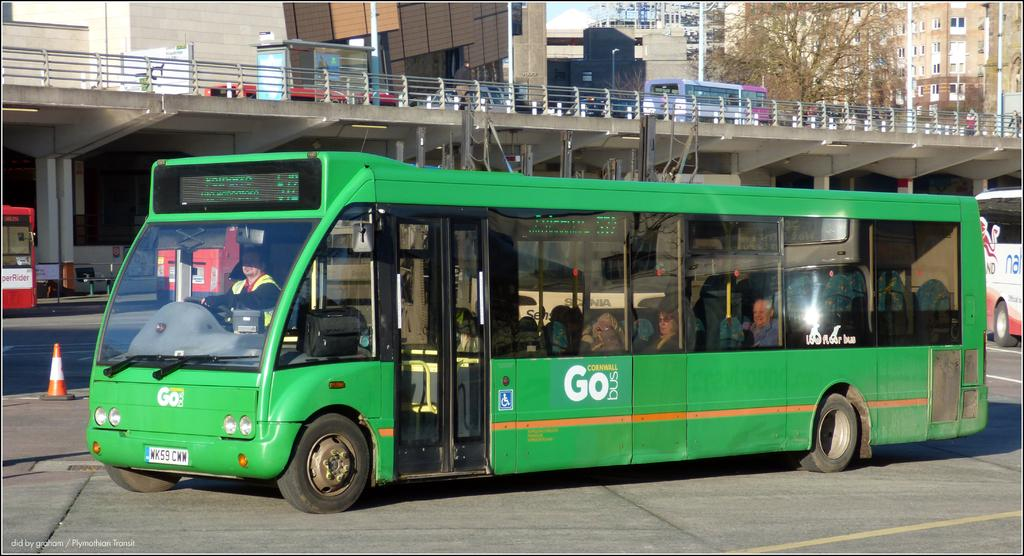<image>
Render a clear and concise summary of the photo. A  green bus in a street with the word Go on the side 